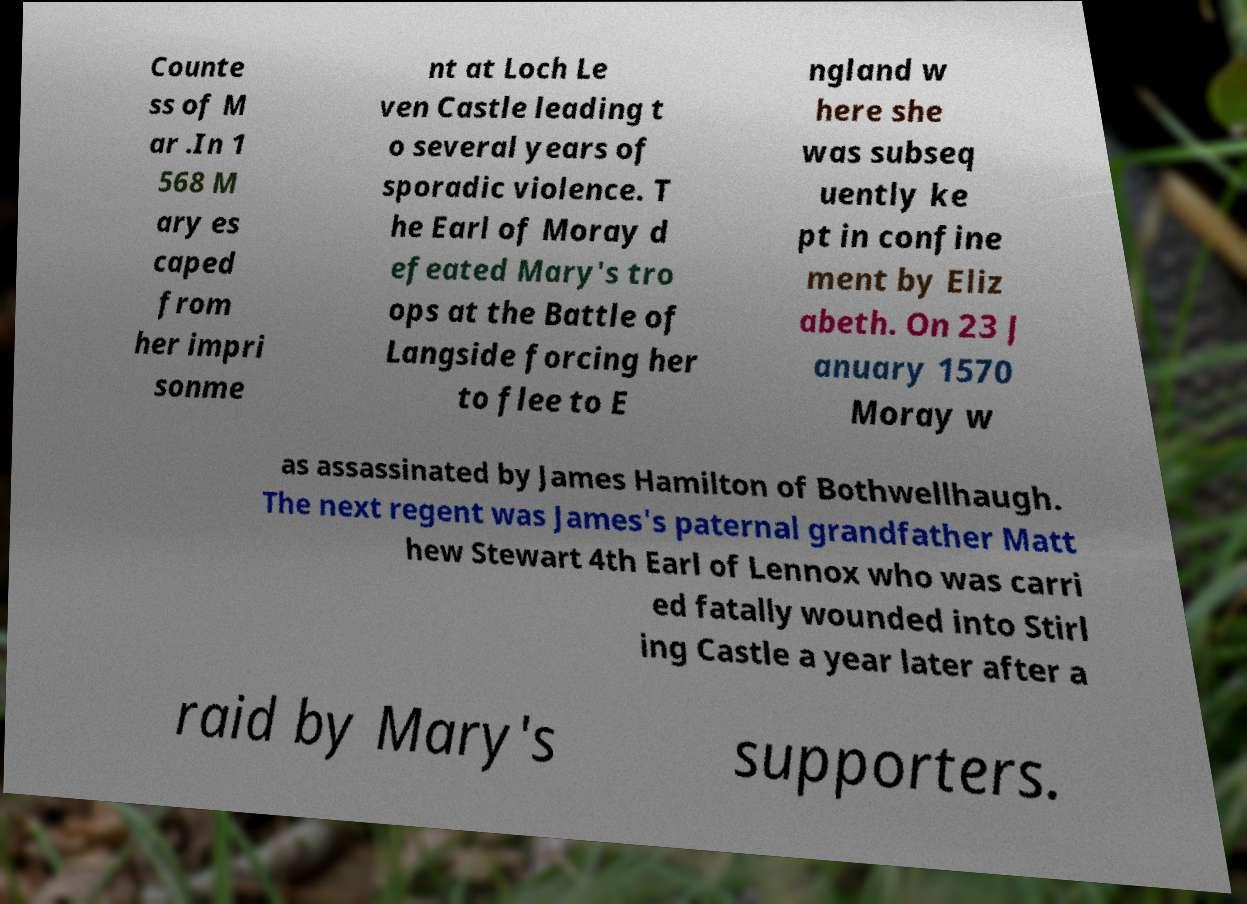For documentation purposes, I need the text within this image transcribed. Could you provide that? Counte ss of M ar .In 1 568 M ary es caped from her impri sonme nt at Loch Le ven Castle leading t o several years of sporadic violence. T he Earl of Moray d efeated Mary's tro ops at the Battle of Langside forcing her to flee to E ngland w here she was subseq uently ke pt in confine ment by Eliz abeth. On 23 J anuary 1570 Moray w as assassinated by James Hamilton of Bothwellhaugh. The next regent was James's paternal grandfather Matt hew Stewart 4th Earl of Lennox who was carri ed fatally wounded into Stirl ing Castle a year later after a raid by Mary's supporters. 